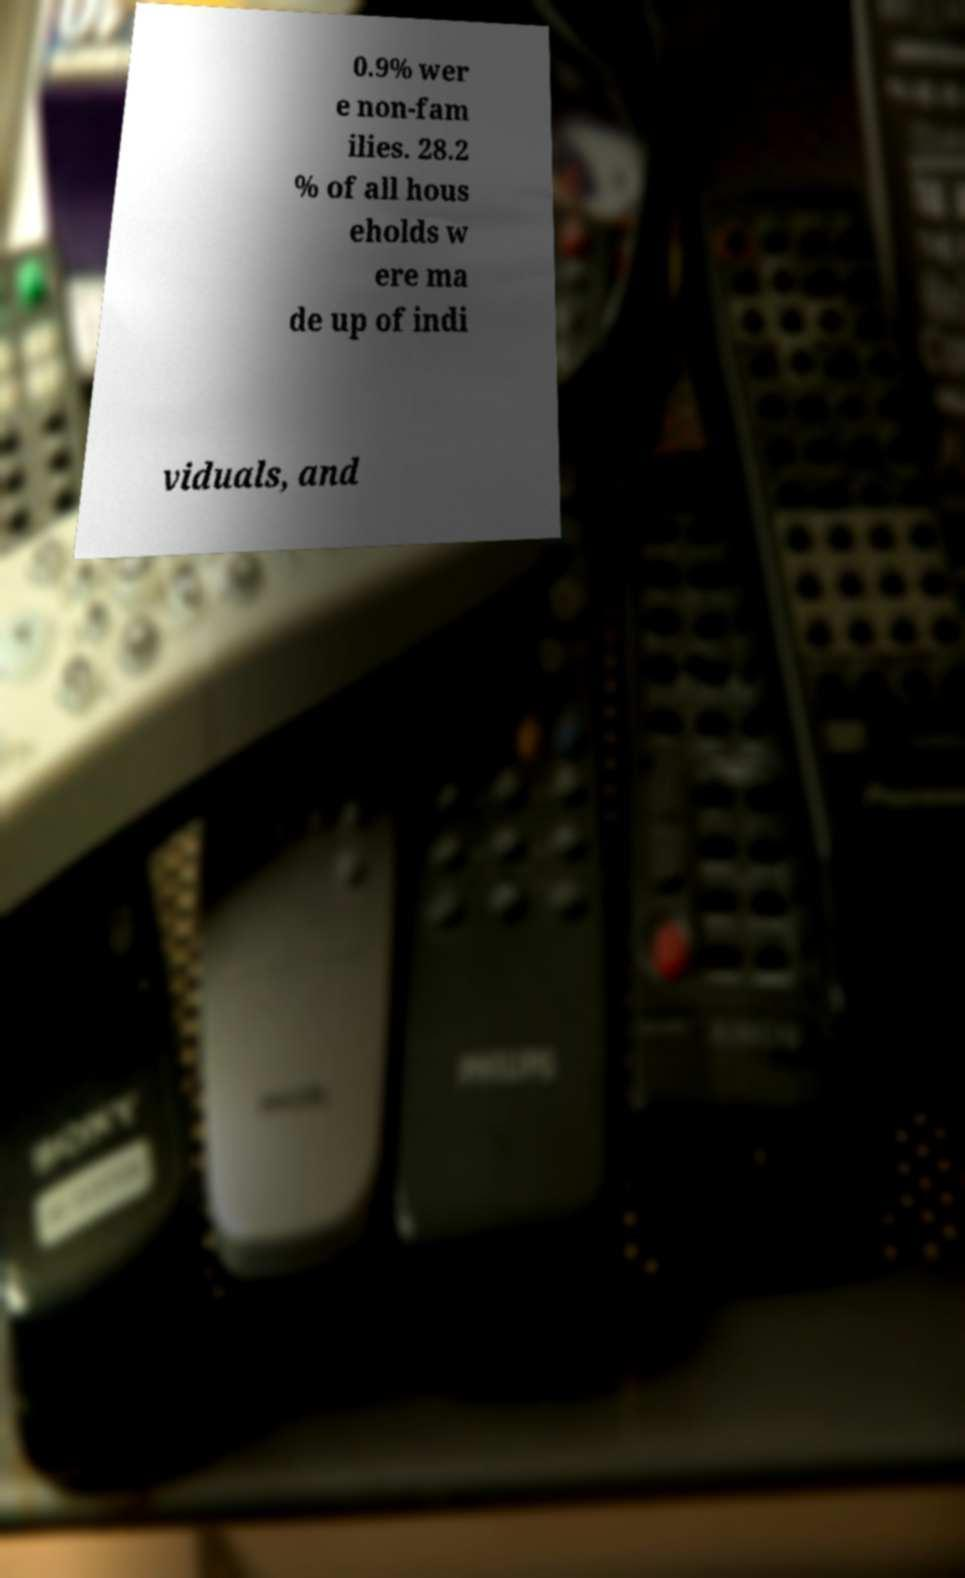I need the written content from this picture converted into text. Can you do that? 0.9% wer e non-fam ilies. 28.2 % of all hous eholds w ere ma de up of indi viduals, and 